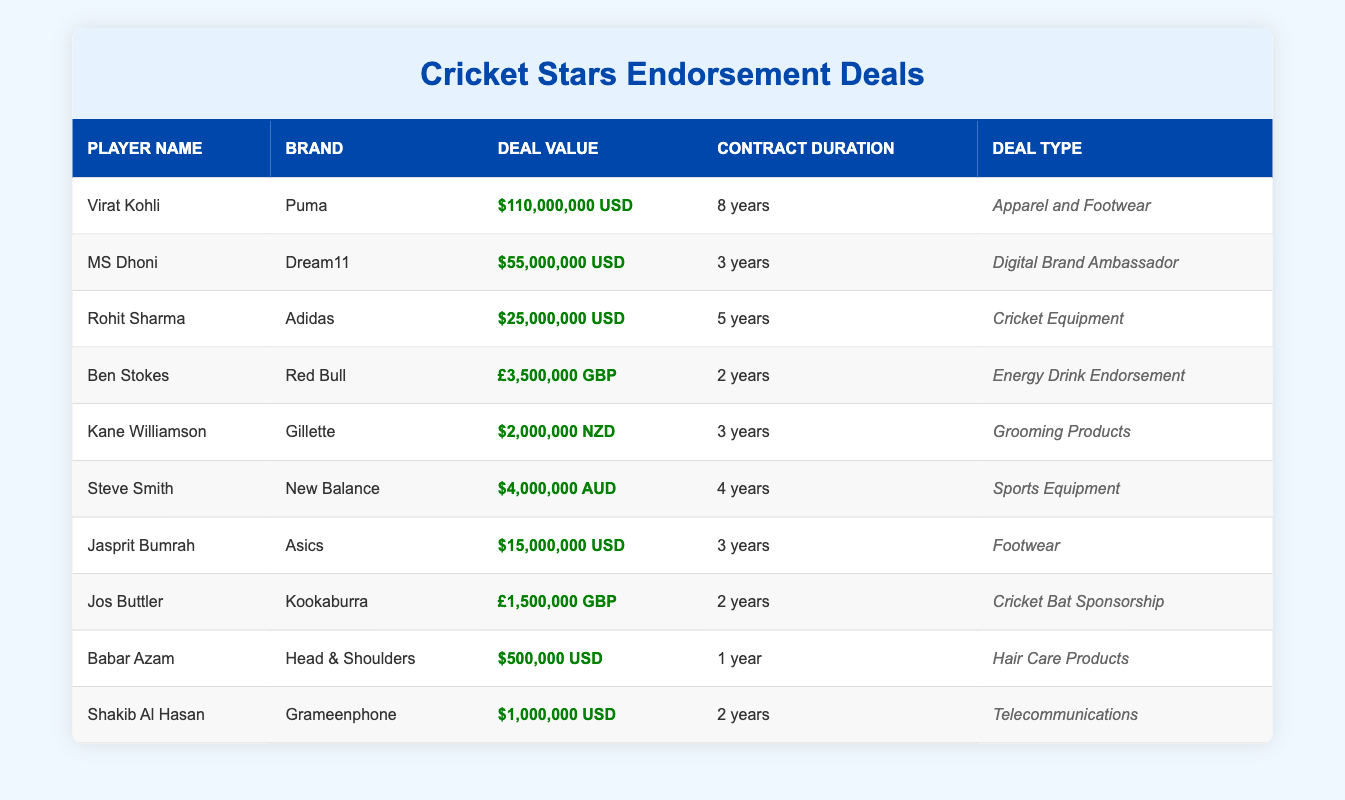What is the total value of endorsement deals for all players listed? Sum up the deal values from each player. The total is $110,000,000 + $55,000,000 + $25,000,000 + £3,500,000 + $2,000,000 + $4,000,000 + $15,000,000 + £1,500,000 + $500,000 + $1,000,000. Converting currencies and adding gives a total of approximately $227,700,000 USD.
Answer: $227,700,000 Who has the highest endorsement deal value? The table shows that Virat Kohli has the highest deal value, which is $110,000,000.
Answer: Virat Kohli Is MS Dhoni's deal duration longer than that of Rohit Sharma? MS Dhoni's deal duration is 3 years, while Rohit Sharma's is 5 years. Since 3 is less than 5, this statement is false.
Answer: No How many years of contract does Ben Stokes have for his endorsement? The table states that Ben Stokes has a contract duration of 2 years.
Answer: 2 years Which player has an endorsement deal with a brand associated with energy drinks? The player with an endorsement deal associated with energy drinks is Ben Stokes, who partnered with Red Bull.
Answer: Ben Stokes What is the combined deal value of players endorsing USD brands? The players endorsing USD brands are Virat Kohli, MS Dhoni, Rohit Sharma, Jasprit Bumrah, Babar Azam, and Shakib Al Hasan. Adding their deal values ($110,000,000 + $55,000,000 + $25,000,000 + $15,000,000 + $500,000 + $1,000,000) gives a total of $211,500,000.
Answer: $211,500,000 Is it true that all players have been endorsed by global brands? Some brands mentioned like Dream11 and Grameenphone are localized. Hence, this statement is not entirely true.
Answer: No Which player has the shortest contract duration? Babar Azam has the shortest contract duration of 1 year as per the table.
Answer: Babar Azam What is the average deal value of players endorsing cricket equipment? The players endorsing cricket equipment are Rohit Sharma and Steve Smith. Their deal values are $25,000,000 and $4,000,000. The total is $29,000,000, and the average is $29,000,000 divided by 2, which is $14,500,000.
Answer: $14,500,000 